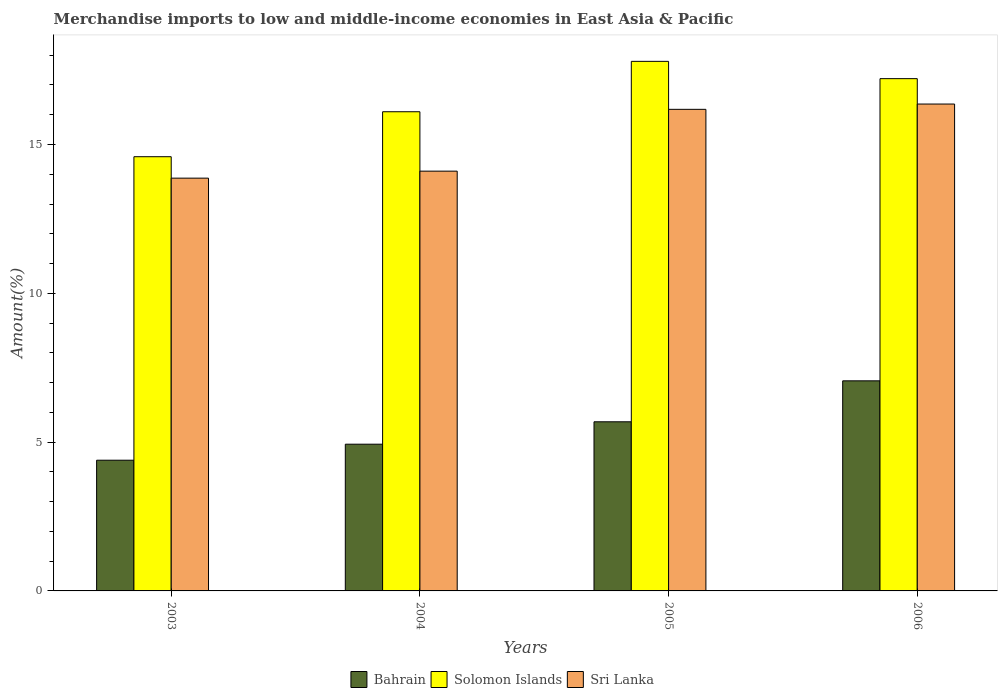How many different coloured bars are there?
Give a very brief answer. 3. Are the number of bars per tick equal to the number of legend labels?
Provide a succinct answer. Yes. How many bars are there on the 1st tick from the right?
Make the answer very short. 3. What is the label of the 2nd group of bars from the left?
Provide a succinct answer. 2004. In how many cases, is the number of bars for a given year not equal to the number of legend labels?
Your response must be concise. 0. What is the percentage of amount earned from merchandise imports in Bahrain in 2006?
Keep it short and to the point. 7.06. Across all years, what is the maximum percentage of amount earned from merchandise imports in Bahrain?
Your response must be concise. 7.06. Across all years, what is the minimum percentage of amount earned from merchandise imports in Solomon Islands?
Keep it short and to the point. 14.59. In which year was the percentage of amount earned from merchandise imports in Sri Lanka maximum?
Your answer should be very brief. 2006. In which year was the percentage of amount earned from merchandise imports in Bahrain minimum?
Offer a very short reply. 2003. What is the total percentage of amount earned from merchandise imports in Sri Lanka in the graph?
Provide a succinct answer. 60.52. What is the difference between the percentage of amount earned from merchandise imports in Bahrain in 2004 and that in 2005?
Your answer should be very brief. -0.75. What is the difference between the percentage of amount earned from merchandise imports in Solomon Islands in 2003 and the percentage of amount earned from merchandise imports in Bahrain in 2005?
Offer a terse response. 8.91. What is the average percentage of amount earned from merchandise imports in Solomon Islands per year?
Offer a very short reply. 16.42. In the year 2005, what is the difference between the percentage of amount earned from merchandise imports in Solomon Islands and percentage of amount earned from merchandise imports in Sri Lanka?
Give a very brief answer. 1.61. What is the ratio of the percentage of amount earned from merchandise imports in Sri Lanka in 2003 to that in 2005?
Your response must be concise. 0.86. Is the percentage of amount earned from merchandise imports in Sri Lanka in 2003 less than that in 2004?
Make the answer very short. Yes. Is the difference between the percentage of amount earned from merchandise imports in Solomon Islands in 2004 and 2006 greater than the difference between the percentage of amount earned from merchandise imports in Sri Lanka in 2004 and 2006?
Keep it short and to the point. Yes. What is the difference between the highest and the second highest percentage of amount earned from merchandise imports in Bahrain?
Ensure brevity in your answer.  1.38. What is the difference between the highest and the lowest percentage of amount earned from merchandise imports in Solomon Islands?
Keep it short and to the point. 3.2. What does the 3rd bar from the left in 2005 represents?
Provide a succinct answer. Sri Lanka. What does the 1st bar from the right in 2003 represents?
Offer a very short reply. Sri Lanka. What is the difference between two consecutive major ticks on the Y-axis?
Keep it short and to the point. 5. Does the graph contain any zero values?
Provide a succinct answer. No. Does the graph contain grids?
Provide a succinct answer. No. How many legend labels are there?
Offer a very short reply. 3. How are the legend labels stacked?
Offer a very short reply. Horizontal. What is the title of the graph?
Ensure brevity in your answer.  Merchandise imports to low and middle-income economies in East Asia & Pacific. What is the label or title of the X-axis?
Keep it short and to the point. Years. What is the label or title of the Y-axis?
Keep it short and to the point. Amount(%). What is the Amount(%) in Bahrain in 2003?
Your answer should be very brief. 4.39. What is the Amount(%) of Solomon Islands in 2003?
Offer a very short reply. 14.59. What is the Amount(%) in Sri Lanka in 2003?
Keep it short and to the point. 13.87. What is the Amount(%) of Bahrain in 2004?
Provide a succinct answer. 4.93. What is the Amount(%) of Solomon Islands in 2004?
Your response must be concise. 16.1. What is the Amount(%) of Sri Lanka in 2004?
Offer a terse response. 14.11. What is the Amount(%) of Bahrain in 2005?
Keep it short and to the point. 5.68. What is the Amount(%) of Solomon Islands in 2005?
Ensure brevity in your answer.  17.79. What is the Amount(%) of Sri Lanka in 2005?
Offer a very short reply. 16.18. What is the Amount(%) of Bahrain in 2006?
Offer a very short reply. 7.06. What is the Amount(%) of Solomon Islands in 2006?
Provide a succinct answer. 17.21. What is the Amount(%) in Sri Lanka in 2006?
Offer a very short reply. 16.36. Across all years, what is the maximum Amount(%) of Bahrain?
Provide a short and direct response. 7.06. Across all years, what is the maximum Amount(%) of Solomon Islands?
Keep it short and to the point. 17.79. Across all years, what is the maximum Amount(%) in Sri Lanka?
Offer a terse response. 16.36. Across all years, what is the minimum Amount(%) in Bahrain?
Your answer should be very brief. 4.39. Across all years, what is the minimum Amount(%) in Solomon Islands?
Offer a very short reply. 14.59. Across all years, what is the minimum Amount(%) of Sri Lanka?
Your answer should be very brief. 13.87. What is the total Amount(%) of Bahrain in the graph?
Offer a very short reply. 22.06. What is the total Amount(%) of Solomon Islands in the graph?
Your answer should be very brief. 65.7. What is the total Amount(%) in Sri Lanka in the graph?
Give a very brief answer. 60.52. What is the difference between the Amount(%) in Bahrain in 2003 and that in 2004?
Your answer should be compact. -0.54. What is the difference between the Amount(%) in Solomon Islands in 2003 and that in 2004?
Your answer should be compact. -1.51. What is the difference between the Amount(%) of Sri Lanka in 2003 and that in 2004?
Keep it short and to the point. -0.24. What is the difference between the Amount(%) in Bahrain in 2003 and that in 2005?
Offer a very short reply. -1.29. What is the difference between the Amount(%) in Solomon Islands in 2003 and that in 2005?
Make the answer very short. -3.2. What is the difference between the Amount(%) in Sri Lanka in 2003 and that in 2005?
Make the answer very short. -2.31. What is the difference between the Amount(%) of Bahrain in 2003 and that in 2006?
Offer a very short reply. -2.67. What is the difference between the Amount(%) of Solomon Islands in 2003 and that in 2006?
Provide a short and direct response. -2.62. What is the difference between the Amount(%) in Sri Lanka in 2003 and that in 2006?
Your answer should be compact. -2.49. What is the difference between the Amount(%) of Bahrain in 2004 and that in 2005?
Keep it short and to the point. -0.75. What is the difference between the Amount(%) in Solomon Islands in 2004 and that in 2005?
Provide a short and direct response. -1.69. What is the difference between the Amount(%) in Sri Lanka in 2004 and that in 2005?
Provide a short and direct response. -2.08. What is the difference between the Amount(%) in Bahrain in 2004 and that in 2006?
Keep it short and to the point. -2.13. What is the difference between the Amount(%) of Solomon Islands in 2004 and that in 2006?
Provide a succinct answer. -1.11. What is the difference between the Amount(%) of Sri Lanka in 2004 and that in 2006?
Your answer should be compact. -2.25. What is the difference between the Amount(%) of Bahrain in 2005 and that in 2006?
Your answer should be compact. -1.38. What is the difference between the Amount(%) of Solomon Islands in 2005 and that in 2006?
Ensure brevity in your answer.  0.58. What is the difference between the Amount(%) of Sri Lanka in 2005 and that in 2006?
Keep it short and to the point. -0.18. What is the difference between the Amount(%) in Bahrain in 2003 and the Amount(%) in Solomon Islands in 2004?
Make the answer very short. -11.71. What is the difference between the Amount(%) of Bahrain in 2003 and the Amount(%) of Sri Lanka in 2004?
Offer a very short reply. -9.71. What is the difference between the Amount(%) in Solomon Islands in 2003 and the Amount(%) in Sri Lanka in 2004?
Offer a very short reply. 0.48. What is the difference between the Amount(%) in Bahrain in 2003 and the Amount(%) in Solomon Islands in 2005?
Offer a very short reply. -13.4. What is the difference between the Amount(%) in Bahrain in 2003 and the Amount(%) in Sri Lanka in 2005?
Ensure brevity in your answer.  -11.79. What is the difference between the Amount(%) in Solomon Islands in 2003 and the Amount(%) in Sri Lanka in 2005?
Your answer should be compact. -1.59. What is the difference between the Amount(%) of Bahrain in 2003 and the Amount(%) of Solomon Islands in 2006?
Keep it short and to the point. -12.82. What is the difference between the Amount(%) in Bahrain in 2003 and the Amount(%) in Sri Lanka in 2006?
Your answer should be very brief. -11.97. What is the difference between the Amount(%) of Solomon Islands in 2003 and the Amount(%) of Sri Lanka in 2006?
Offer a very short reply. -1.77. What is the difference between the Amount(%) in Bahrain in 2004 and the Amount(%) in Solomon Islands in 2005?
Your answer should be very brief. -12.86. What is the difference between the Amount(%) of Bahrain in 2004 and the Amount(%) of Sri Lanka in 2005?
Offer a very short reply. -11.25. What is the difference between the Amount(%) in Solomon Islands in 2004 and the Amount(%) in Sri Lanka in 2005?
Keep it short and to the point. -0.08. What is the difference between the Amount(%) in Bahrain in 2004 and the Amount(%) in Solomon Islands in 2006?
Provide a succinct answer. -12.28. What is the difference between the Amount(%) in Bahrain in 2004 and the Amount(%) in Sri Lanka in 2006?
Your answer should be compact. -11.43. What is the difference between the Amount(%) in Solomon Islands in 2004 and the Amount(%) in Sri Lanka in 2006?
Provide a succinct answer. -0.26. What is the difference between the Amount(%) of Bahrain in 2005 and the Amount(%) of Solomon Islands in 2006?
Provide a short and direct response. -11.53. What is the difference between the Amount(%) of Bahrain in 2005 and the Amount(%) of Sri Lanka in 2006?
Your answer should be compact. -10.68. What is the difference between the Amount(%) in Solomon Islands in 2005 and the Amount(%) in Sri Lanka in 2006?
Give a very brief answer. 1.43. What is the average Amount(%) of Bahrain per year?
Provide a succinct answer. 5.52. What is the average Amount(%) of Solomon Islands per year?
Make the answer very short. 16.42. What is the average Amount(%) of Sri Lanka per year?
Make the answer very short. 15.13. In the year 2003, what is the difference between the Amount(%) of Bahrain and Amount(%) of Solomon Islands?
Your answer should be very brief. -10.2. In the year 2003, what is the difference between the Amount(%) of Bahrain and Amount(%) of Sri Lanka?
Provide a succinct answer. -9.48. In the year 2003, what is the difference between the Amount(%) in Solomon Islands and Amount(%) in Sri Lanka?
Provide a succinct answer. 0.72. In the year 2004, what is the difference between the Amount(%) in Bahrain and Amount(%) in Solomon Islands?
Provide a succinct answer. -11.17. In the year 2004, what is the difference between the Amount(%) of Bahrain and Amount(%) of Sri Lanka?
Ensure brevity in your answer.  -9.18. In the year 2004, what is the difference between the Amount(%) in Solomon Islands and Amount(%) in Sri Lanka?
Offer a terse response. 2. In the year 2005, what is the difference between the Amount(%) of Bahrain and Amount(%) of Solomon Islands?
Offer a terse response. -12.11. In the year 2005, what is the difference between the Amount(%) of Bahrain and Amount(%) of Sri Lanka?
Give a very brief answer. -10.5. In the year 2005, what is the difference between the Amount(%) in Solomon Islands and Amount(%) in Sri Lanka?
Your answer should be compact. 1.61. In the year 2006, what is the difference between the Amount(%) in Bahrain and Amount(%) in Solomon Islands?
Your response must be concise. -10.15. In the year 2006, what is the difference between the Amount(%) of Bahrain and Amount(%) of Sri Lanka?
Give a very brief answer. -9.3. In the year 2006, what is the difference between the Amount(%) in Solomon Islands and Amount(%) in Sri Lanka?
Your answer should be compact. 0.85. What is the ratio of the Amount(%) of Bahrain in 2003 to that in 2004?
Keep it short and to the point. 0.89. What is the ratio of the Amount(%) of Solomon Islands in 2003 to that in 2004?
Your answer should be very brief. 0.91. What is the ratio of the Amount(%) in Sri Lanka in 2003 to that in 2004?
Provide a short and direct response. 0.98. What is the ratio of the Amount(%) in Bahrain in 2003 to that in 2005?
Your answer should be very brief. 0.77. What is the ratio of the Amount(%) in Solomon Islands in 2003 to that in 2005?
Provide a short and direct response. 0.82. What is the ratio of the Amount(%) in Bahrain in 2003 to that in 2006?
Your response must be concise. 0.62. What is the ratio of the Amount(%) in Solomon Islands in 2003 to that in 2006?
Keep it short and to the point. 0.85. What is the ratio of the Amount(%) in Sri Lanka in 2003 to that in 2006?
Give a very brief answer. 0.85. What is the ratio of the Amount(%) of Bahrain in 2004 to that in 2005?
Offer a very short reply. 0.87. What is the ratio of the Amount(%) of Solomon Islands in 2004 to that in 2005?
Your response must be concise. 0.9. What is the ratio of the Amount(%) of Sri Lanka in 2004 to that in 2005?
Make the answer very short. 0.87. What is the ratio of the Amount(%) in Bahrain in 2004 to that in 2006?
Provide a succinct answer. 0.7. What is the ratio of the Amount(%) in Solomon Islands in 2004 to that in 2006?
Provide a short and direct response. 0.94. What is the ratio of the Amount(%) of Sri Lanka in 2004 to that in 2006?
Your answer should be compact. 0.86. What is the ratio of the Amount(%) of Bahrain in 2005 to that in 2006?
Keep it short and to the point. 0.81. What is the ratio of the Amount(%) of Solomon Islands in 2005 to that in 2006?
Offer a terse response. 1.03. What is the difference between the highest and the second highest Amount(%) in Bahrain?
Provide a succinct answer. 1.38. What is the difference between the highest and the second highest Amount(%) of Solomon Islands?
Make the answer very short. 0.58. What is the difference between the highest and the second highest Amount(%) of Sri Lanka?
Provide a short and direct response. 0.18. What is the difference between the highest and the lowest Amount(%) of Bahrain?
Offer a terse response. 2.67. What is the difference between the highest and the lowest Amount(%) of Solomon Islands?
Offer a very short reply. 3.2. What is the difference between the highest and the lowest Amount(%) in Sri Lanka?
Keep it short and to the point. 2.49. 